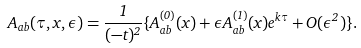Convert formula to latex. <formula><loc_0><loc_0><loc_500><loc_500>A _ { a b } ( \tau , x , \epsilon ) = \frac { 1 } { ( - t ) ^ { 2 } } \{ { A _ { a b } ^ { ( 0 ) } ( x ) + \epsilon A _ { a b } ^ { ( 1 ) } ( x ) e ^ { k \tau } + O ( \epsilon ^ { 2 } ) } \} .</formula> 